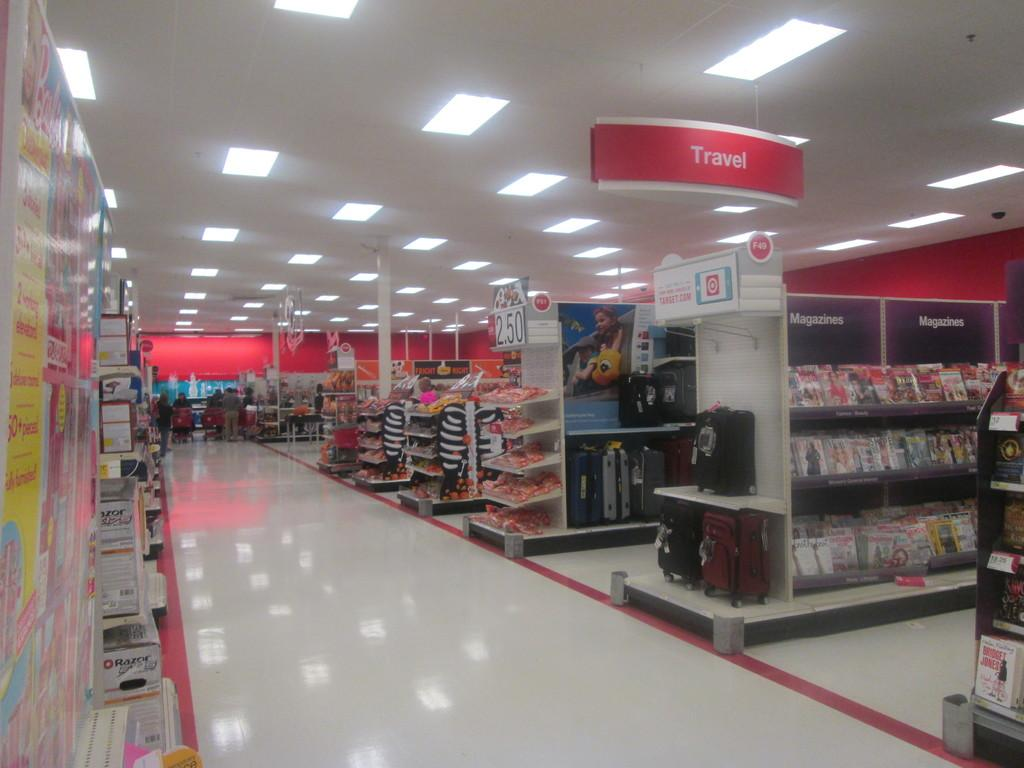Provide a one-sentence caption for the provided image. Travel section inside of a department store with some candy on an end isle for $2.50. 